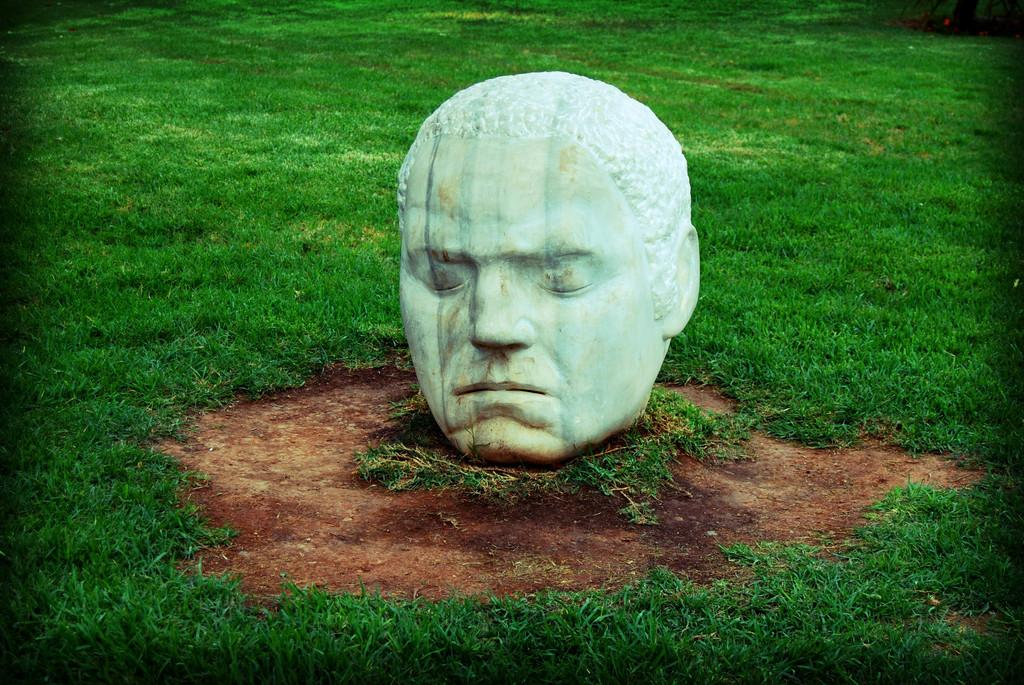What is the main subject of the image? There is a sculpture of a head in the image. What is the surrounding environment like? There is a lot of grass around the sculpture. Can you hear the bell ringing in the image? There is no bell present in the image, so it cannot be heard ringing. 